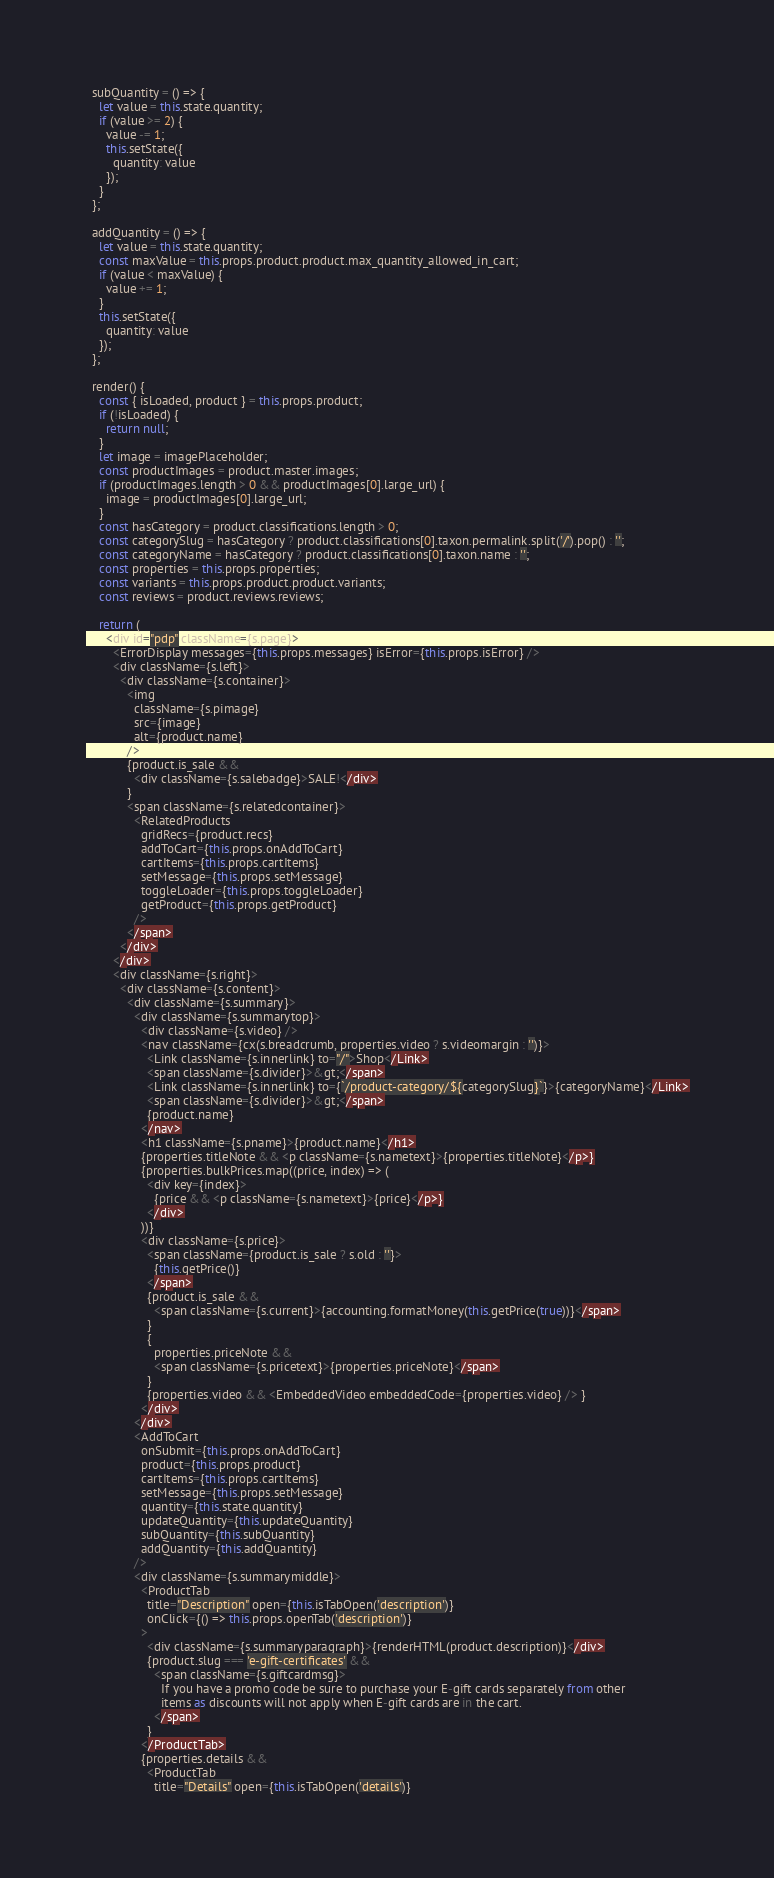<code> <loc_0><loc_0><loc_500><loc_500><_JavaScript_>  subQuantity = () => {
    let value = this.state.quantity;
    if (value >= 2) {
      value -= 1;
      this.setState({
        quantity: value
      });
    }
  };

  addQuantity = () => {
    let value = this.state.quantity;
    const maxValue = this.props.product.product.max_quantity_allowed_in_cart;
    if (value < maxValue) {
      value += 1;
    }
    this.setState({
      quantity: value
    });
  };

  render() {
    const { isLoaded, product } = this.props.product;
    if (!isLoaded) {
      return null;
    }
    let image = imagePlaceholder;
    const productImages = product.master.images;
    if (productImages.length > 0 && productImages[0].large_url) {
      image = productImages[0].large_url;
    }
    const hasCategory = product.classifications.length > 0;
    const categorySlug = hasCategory ? product.classifications[0].taxon.permalink.split('/').pop() : '';
    const categoryName = hasCategory ? product.classifications[0].taxon.name : '';
    const properties = this.props.properties;
    const variants = this.props.product.product.variants;
    const reviews = product.reviews.reviews;

    return (
      <div id="pdp" className={s.page}>
        <ErrorDisplay messages={this.props.messages} isError={this.props.isError} />
        <div className={s.left}>
          <div className={s.container}>
            <img
              className={s.pimage}
              src={image}
              alt={product.name}
            />
            {product.is_sale &&
              <div className={s.salebadge}>SALE!</div>
            }
            <span className={s.relatedcontainer}>
              <RelatedProducts
                gridRecs={product.recs}
                addToCart={this.props.onAddToCart}
                cartItems={this.props.cartItems}
                setMessage={this.props.setMessage}
                toggleLoader={this.props.toggleLoader}
                getProduct={this.props.getProduct}
              />
            </span>
          </div>
        </div>
        <div className={s.right}>
          <div className={s.content}>
            <div className={s.summary}>
              <div className={s.summarytop}>
                <div className={s.video} />
                <nav className={cx(s.breadcrumb, properties.video ? s.videomargin : '')}>
                  <Link className={s.innerlink} to="/">Shop</Link>
                  <span className={s.divider}>&gt;</span>
                  <Link className={s.innerlink} to={`/product-category/${categorySlug}`}>{categoryName}</Link>
                  <span className={s.divider}>&gt;</span>
                  {product.name}
                </nav>
                <h1 className={s.pname}>{product.name}</h1>
                {properties.titleNote && <p className={s.nametext}>{properties.titleNote}</p>}
                {properties.bulkPrices.map((price, index) => (
                  <div key={index}>
                    {price && <p className={s.nametext}>{price}</p>}
                  </div>
                ))}
                <div className={s.price}>
                  <span className={product.is_sale ? s.old : ''}>
                    {this.getPrice()}
                  </span>
                  {product.is_sale &&
                    <span className={s.current}>{accounting.formatMoney(this.getPrice(true))}</span>
                  }
                  {
                    properties.priceNote &&
                    <span className={s.pricetext}>{properties.priceNote}</span>
                  }
                  {properties.video && <EmbeddedVideo embeddedCode={properties.video} /> }
                </div>
              </div>
              <AddToCart
                onSubmit={this.props.onAddToCart}
                product={this.props.product}
                cartItems={this.props.cartItems}
                setMessage={this.props.setMessage}
                quantity={this.state.quantity}
                updateQuantity={this.updateQuantity}
                subQuantity={this.subQuantity}
                addQuantity={this.addQuantity}
              />
              <div className={s.summarymiddle}>
                <ProductTab
                  title="Description" open={this.isTabOpen('description')}
                  onClick={() => this.props.openTab('description')}
                >
                  <div className={s.summaryparagraph}>{renderHTML(product.description)}</div>
                  {product.slug === 'e-gift-certificates' &&
                    <span className={s.giftcardmsg}>
                      If you have a promo code be sure to purchase your E-gift cards separately from other
                      items as discounts will not apply when E-gift cards are in the cart.
                    </span>
                  }
                </ProductTab>
                {properties.details &&
                  <ProductTab
                    title="Details" open={this.isTabOpen('details')}</code> 